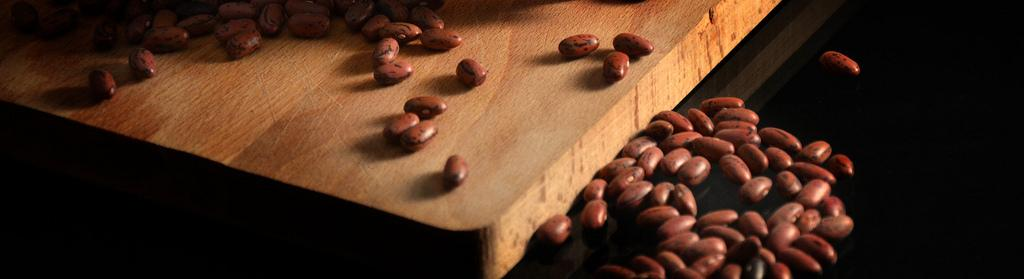What is the main object in the image? There is a wooden plank in the image. What is on top of the wooden plank? There are brown beans on the wooden plank. Are there any beans on the floor in the image? Yes, there are beans on the floor in the image. What type of bear can be seen interacting with the beans on the wooden plank in the image? There is no bear present in the image; it only features a wooden plank with brown beans on it and beans on the floor. What kind of apparatus is used to measure the beans on the wooden plank in the image? There is no apparatus present in the image for measuring the beans; it only shows the wooden plank with beans on it and beans on the floor. 